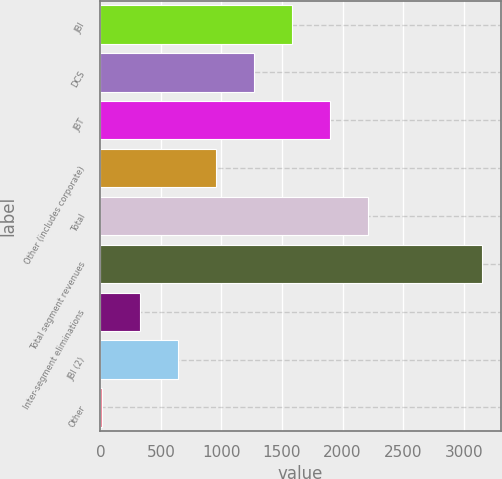<chart> <loc_0><loc_0><loc_500><loc_500><bar_chart><fcel>JBI<fcel>DCS<fcel>JBT<fcel>Other (includes corporate)<fcel>Total<fcel>Total segment revenues<fcel>Inter-segment eliminations<fcel>JBI (2)<fcel>Other<nl><fcel>1579.5<fcel>1265.8<fcel>1893.2<fcel>952.1<fcel>2206.9<fcel>3148<fcel>324.7<fcel>638.4<fcel>11<nl></chart> 